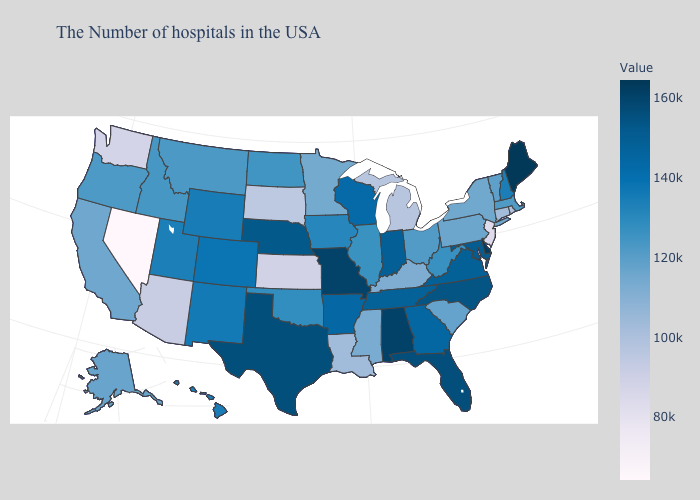Among the states that border New Mexico , does Utah have the highest value?
Give a very brief answer. No. Does Arizona have the highest value in the West?
Quick response, please. No. Is the legend a continuous bar?
Give a very brief answer. Yes. Is the legend a continuous bar?
Write a very short answer. Yes. Among the states that border Connecticut , which have the lowest value?
Give a very brief answer. Rhode Island. Which states have the highest value in the USA?
Answer briefly. Maine. 